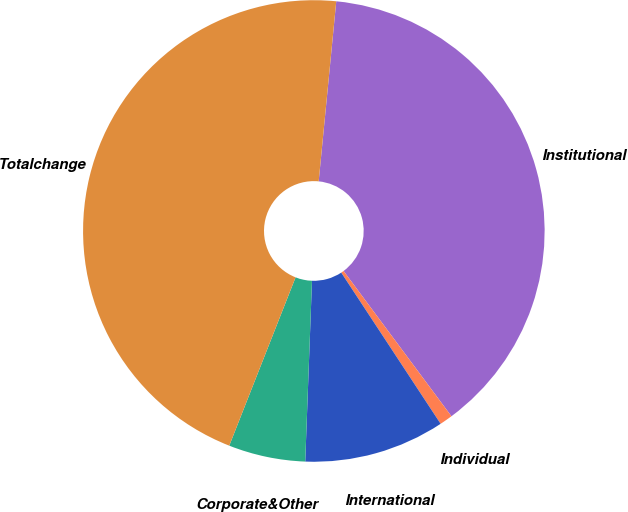<chart> <loc_0><loc_0><loc_500><loc_500><pie_chart><fcel>Institutional<fcel>Individual<fcel>International<fcel>Corporate&Other<fcel>Totalchange<nl><fcel>38.29%<fcel>0.91%<fcel>9.85%<fcel>5.38%<fcel>45.58%<nl></chart> 